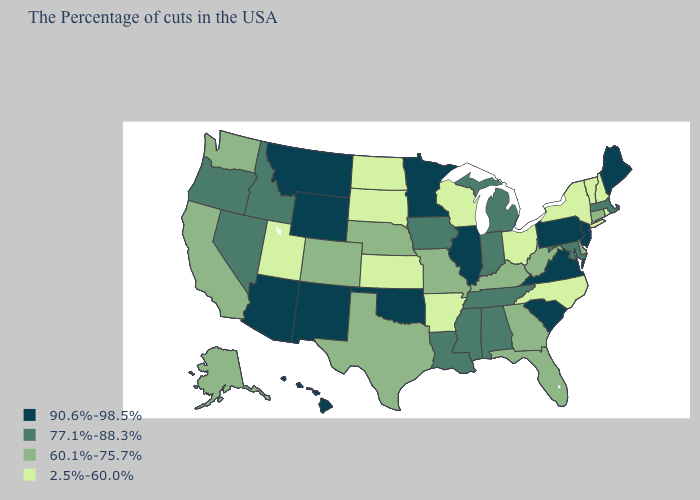Does Vermont have the same value as Oklahoma?
Quick response, please. No. Among the states that border Ohio , which have the highest value?
Short answer required. Pennsylvania. Does Arizona have the same value as Oklahoma?
Write a very short answer. Yes. Which states have the lowest value in the USA?
Concise answer only. Rhode Island, New Hampshire, Vermont, New York, North Carolina, Ohio, Wisconsin, Arkansas, Kansas, South Dakota, North Dakota, Utah. What is the value of Alabama?
Short answer required. 77.1%-88.3%. Name the states that have a value in the range 60.1%-75.7%?
Give a very brief answer. Connecticut, Delaware, West Virginia, Florida, Georgia, Kentucky, Missouri, Nebraska, Texas, Colorado, California, Washington, Alaska. Name the states that have a value in the range 60.1%-75.7%?
Be succinct. Connecticut, Delaware, West Virginia, Florida, Georgia, Kentucky, Missouri, Nebraska, Texas, Colorado, California, Washington, Alaska. Name the states that have a value in the range 2.5%-60.0%?
Be succinct. Rhode Island, New Hampshire, Vermont, New York, North Carolina, Ohio, Wisconsin, Arkansas, Kansas, South Dakota, North Dakota, Utah. What is the lowest value in states that border Idaho?
Give a very brief answer. 2.5%-60.0%. Name the states that have a value in the range 2.5%-60.0%?
Be succinct. Rhode Island, New Hampshire, Vermont, New York, North Carolina, Ohio, Wisconsin, Arkansas, Kansas, South Dakota, North Dakota, Utah. Name the states that have a value in the range 2.5%-60.0%?
Keep it brief. Rhode Island, New Hampshire, Vermont, New York, North Carolina, Ohio, Wisconsin, Arkansas, Kansas, South Dakota, North Dakota, Utah. What is the highest value in the Northeast ?
Keep it brief. 90.6%-98.5%. Name the states that have a value in the range 77.1%-88.3%?
Give a very brief answer. Massachusetts, Maryland, Michigan, Indiana, Alabama, Tennessee, Mississippi, Louisiana, Iowa, Idaho, Nevada, Oregon. Does Mississippi have the highest value in the USA?
Concise answer only. No. Is the legend a continuous bar?
Quick response, please. No. 